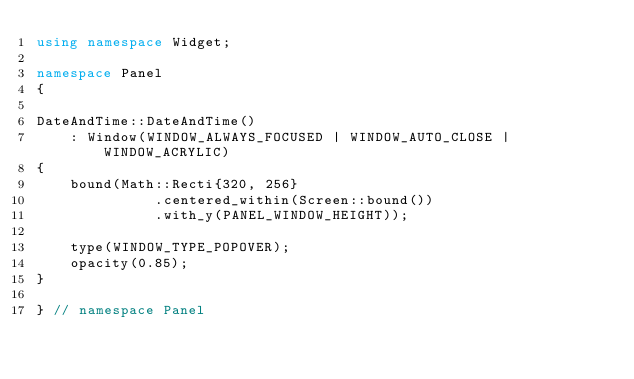<code> <loc_0><loc_0><loc_500><loc_500><_C++_>using namespace Widget;

namespace Panel
{

DateAndTime::DateAndTime()
    : Window(WINDOW_ALWAYS_FOCUSED | WINDOW_AUTO_CLOSE | WINDOW_ACRYLIC)
{
    bound(Math::Recti{320, 256}
              .centered_within(Screen::bound())
              .with_y(PANEL_WINDOW_HEIGHT));

    type(WINDOW_TYPE_POPOVER);
    opacity(0.85);
}

} // namespace Panel</code> 